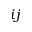<formula> <loc_0><loc_0><loc_500><loc_500>i j</formula> 